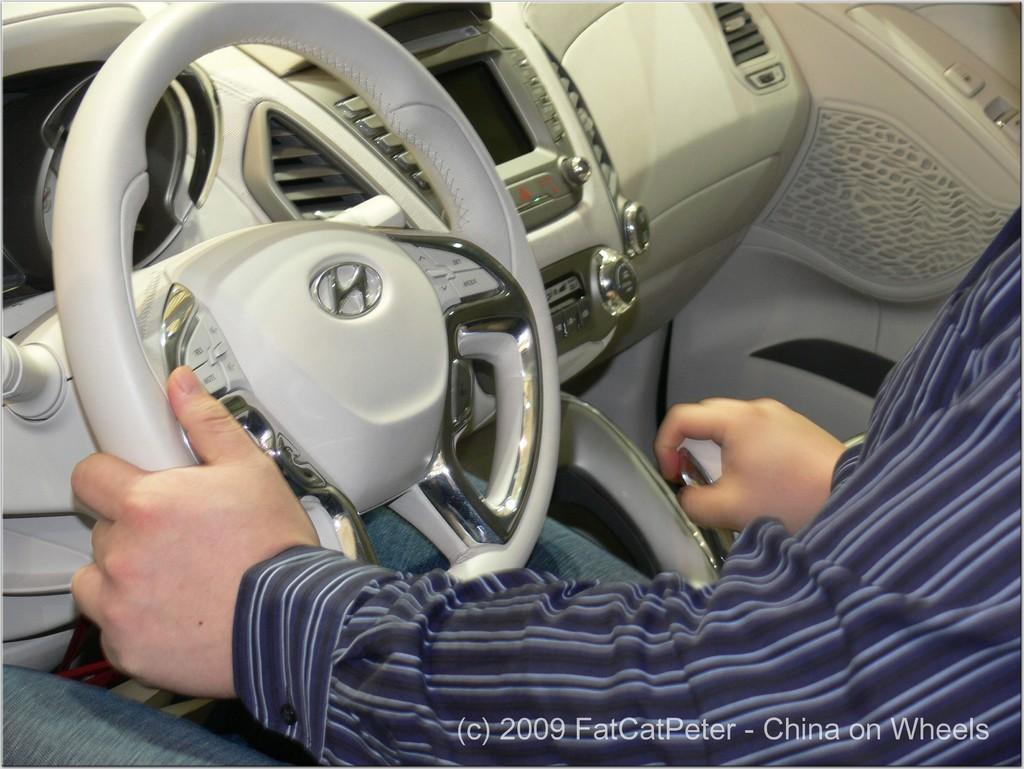Can you describe this image briefly? This picture is an inside view of a car. I this picture we can see a man is sitting and holding a steering and also we can see the buttons, screen and some other objects. In the bottom right corner we can see the text. 